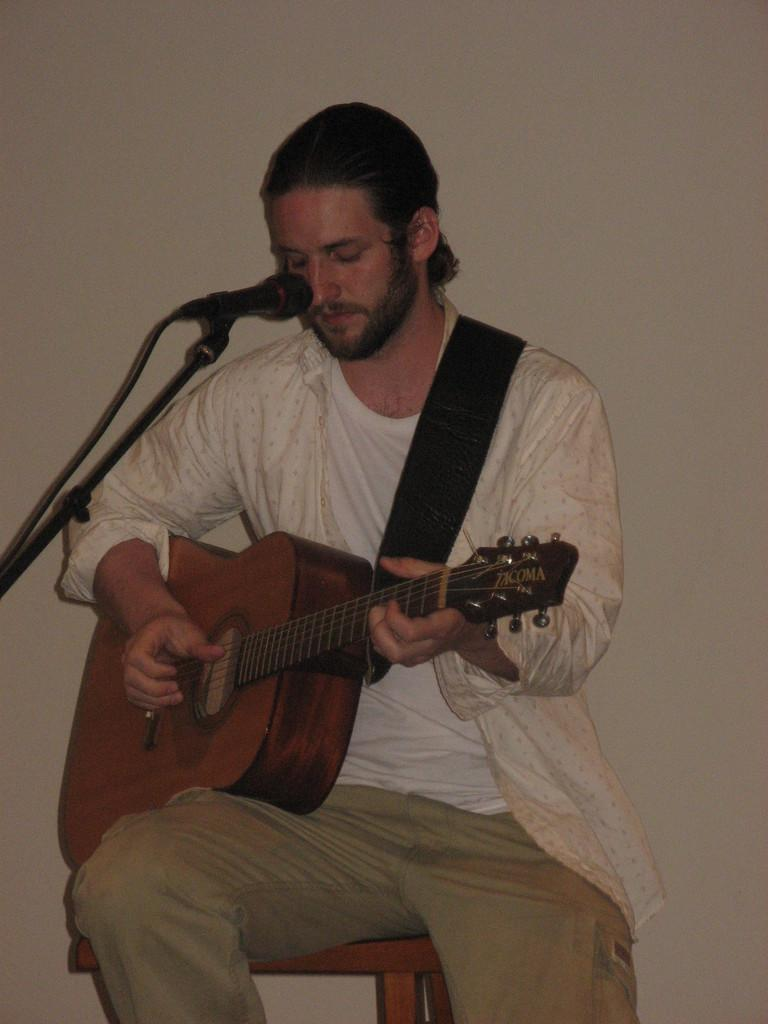Who is the main subject in the image? There is a man in the image. What is the man doing in the image? The man is seated and playing a guitar. What object is in front of the man? There is a microphone in front of the man. What type of flower is being used to support the guitar in the image? There is no flower present in the image, and the guitar is not being supported by any object. 